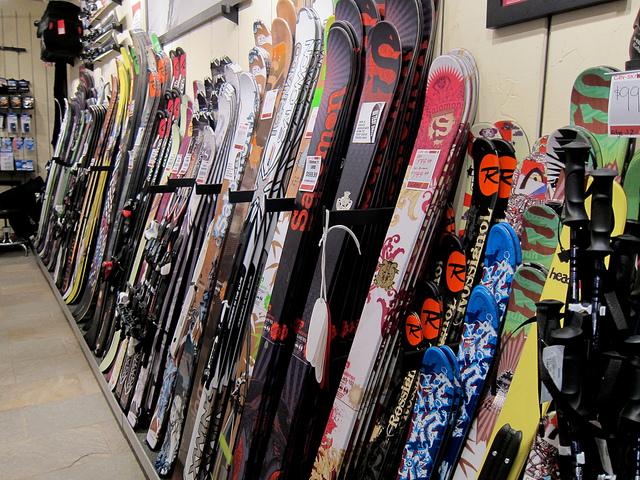What color is the cart holding the skis?
Write a very short answer. Black. How many boards are against the wall?
Answer briefly. Many. Are these expensive?
Quick response, please. Yes. What are these?
Keep it brief. Skis. Are the skis on the train or next to it?
Give a very brief answer. Next to it. 